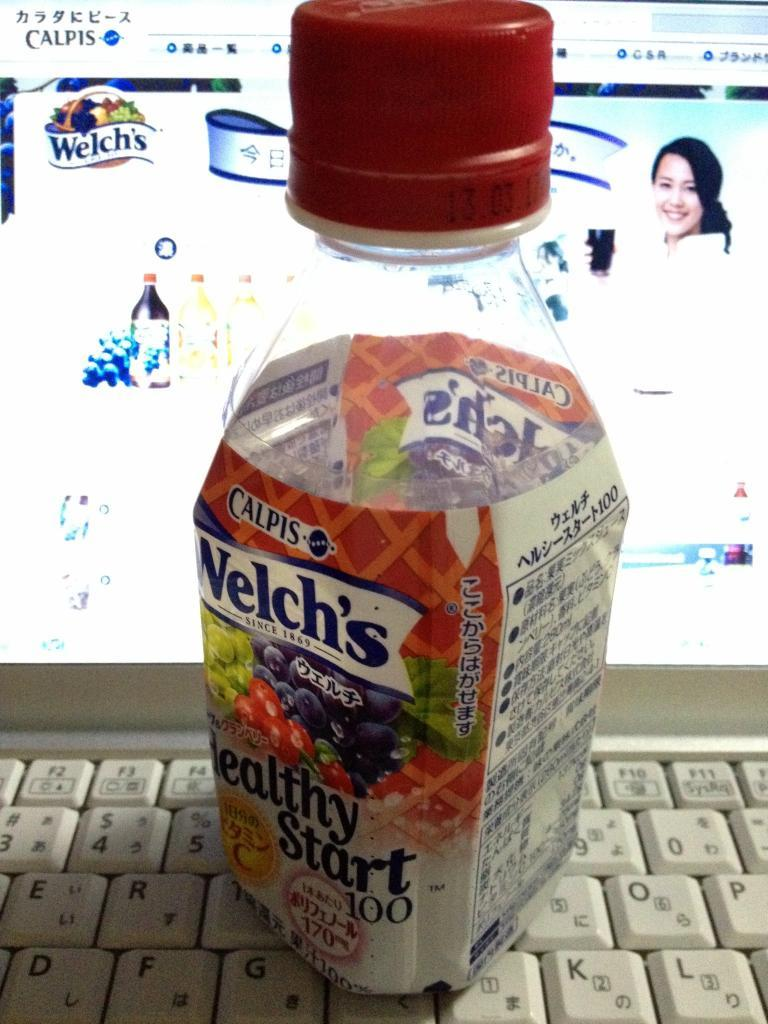Provide a one-sentence caption for the provided image. A bottle of Welch's healthy start 100 juice with words written in chinease. 